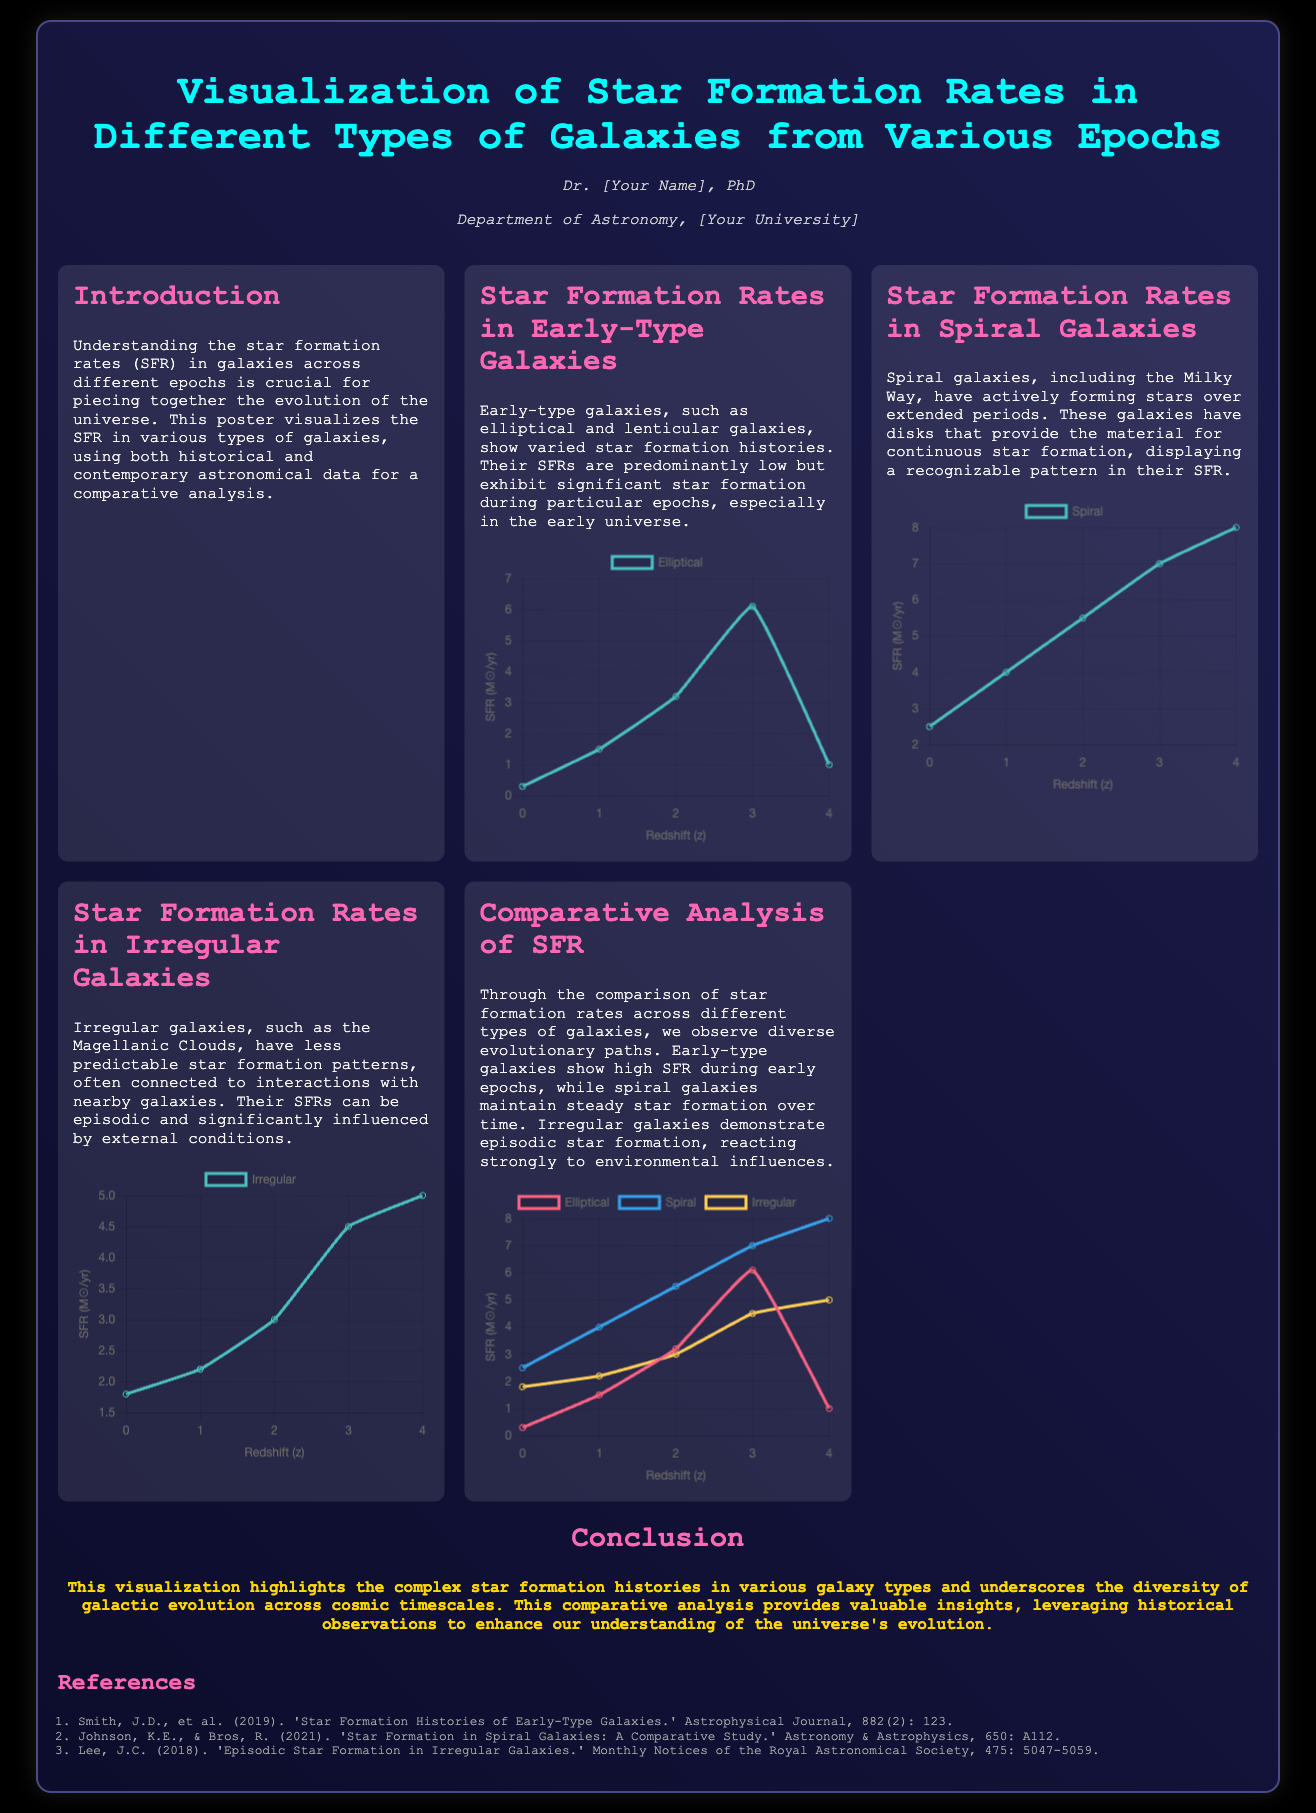What is the title of the poster? The title is prominently displayed at the top of the poster, which is "Visualization of Star Formation Rates in Different Types of Galaxies from Various Epochs."
Answer: Visualization of Star Formation Rates in Different Types of Galaxies from Various Epochs Who is the author of the poster? The author's name is indicated in the header section of the poster, which states "Dr. [Your Name], PhD."
Answer: Dr. [Your Name], PhD What type of galaxies shows predominantly low star formation rates? The section on "Star Formation Rates in Early-Type Galaxies" discusses this characteristic.
Answer: Early-type galaxies What color represents Spiral galaxies in the comparative chart? The chart's datasets use specific colors to identify different types of galaxies; Spiral galaxies are marked in blue.
Answer: Blue What is the range of star formation rates for irregular galaxies shown in the chart? The data points for irregular galaxies are provided in a specific sequence reflecting their SFR values.
Answer: 1.8 to 5.0 Which section of the poster discusses environmental influences on star formation? This information can be found in the section specifically focused on irregular galaxies.
Answer: Star Formation Rates in Irregular Galaxies What year was the reference by Johnson and Bros published? The references section lists the year of publication for each cited work.
Answer: 2021 How many datasets are plotted in the comparative analysis chart? The comparative chart includes a dataset for each of the three types of galaxies discussed.
Answer: Three 